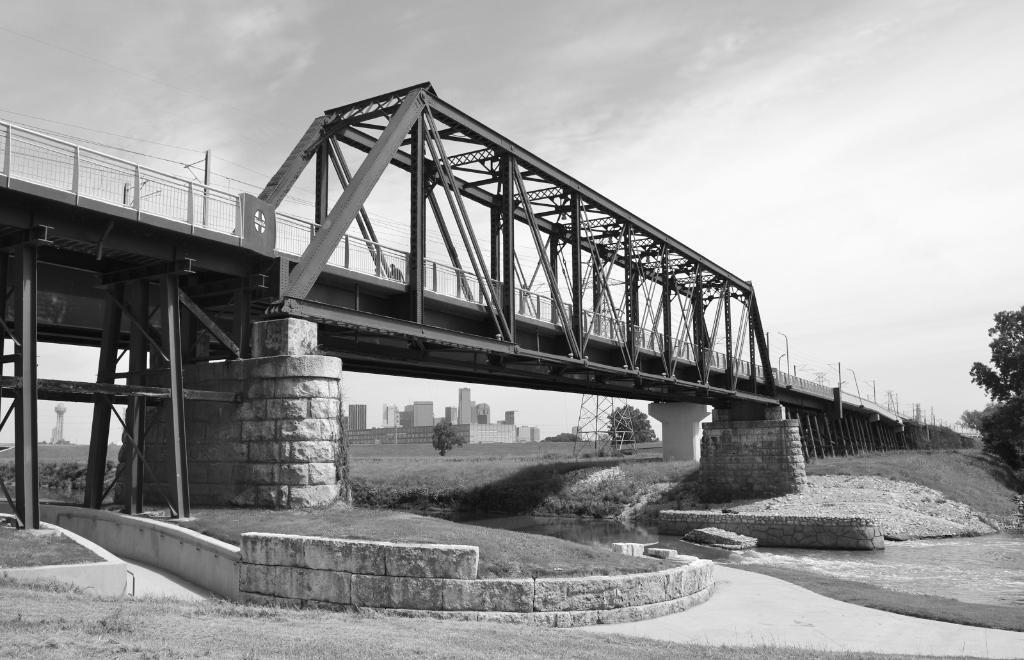How would you summarize this image in a sentence or two? This picture is clicked outside. In the foreground we can see a water body, grass, trees and the metal rods. In the center we can see the bridge and the metal objects and the pillars. In the background we can see the sky and the buildings and some other objects. 